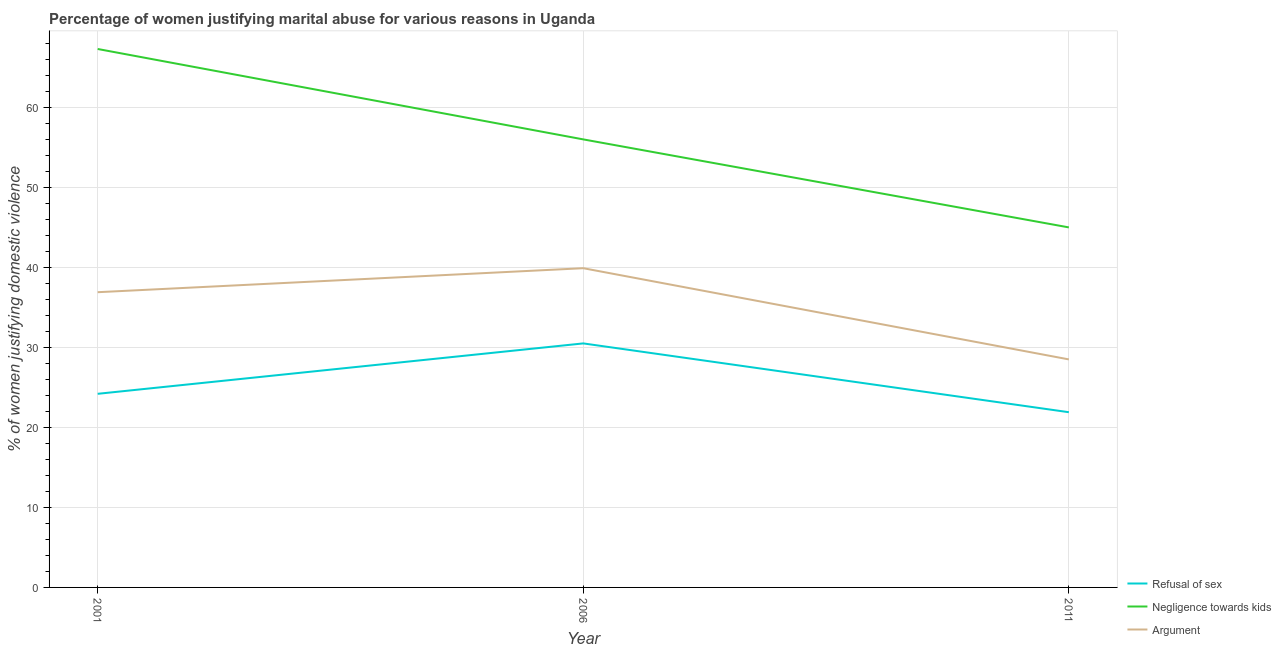How many different coloured lines are there?
Ensure brevity in your answer.  3. Does the line corresponding to percentage of women justifying domestic violence due to negligence towards kids intersect with the line corresponding to percentage of women justifying domestic violence due to arguments?
Give a very brief answer. No. Is the number of lines equal to the number of legend labels?
Make the answer very short. Yes. What is the percentage of women justifying domestic violence due to refusal of sex in 2011?
Your answer should be very brief. 21.9. Across all years, what is the maximum percentage of women justifying domestic violence due to refusal of sex?
Offer a very short reply. 30.5. In which year was the percentage of women justifying domestic violence due to negligence towards kids maximum?
Offer a very short reply. 2001. What is the total percentage of women justifying domestic violence due to refusal of sex in the graph?
Your answer should be compact. 76.6. What is the difference between the percentage of women justifying domestic violence due to negligence towards kids in 2001 and that in 2006?
Your answer should be compact. 11.3. What is the average percentage of women justifying domestic violence due to arguments per year?
Offer a terse response. 35.1. In the year 2011, what is the difference between the percentage of women justifying domestic violence due to arguments and percentage of women justifying domestic violence due to refusal of sex?
Ensure brevity in your answer.  6.6. In how many years, is the percentage of women justifying domestic violence due to refusal of sex greater than 60 %?
Keep it short and to the point. 0. What is the ratio of the percentage of women justifying domestic violence due to negligence towards kids in 2001 to that in 2011?
Provide a short and direct response. 1.5. Is the percentage of women justifying domestic violence due to refusal of sex in 2001 less than that in 2011?
Your response must be concise. No. What is the difference between the highest and the second highest percentage of women justifying domestic violence due to negligence towards kids?
Give a very brief answer. 11.3. What is the difference between the highest and the lowest percentage of women justifying domestic violence due to negligence towards kids?
Your response must be concise. 22.3. In how many years, is the percentage of women justifying domestic violence due to refusal of sex greater than the average percentage of women justifying domestic violence due to refusal of sex taken over all years?
Your answer should be compact. 1. Is it the case that in every year, the sum of the percentage of women justifying domestic violence due to refusal of sex and percentage of women justifying domestic violence due to negligence towards kids is greater than the percentage of women justifying domestic violence due to arguments?
Offer a terse response. Yes. Does the percentage of women justifying domestic violence due to negligence towards kids monotonically increase over the years?
Give a very brief answer. No. Is the percentage of women justifying domestic violence due to arguments strictly greater than the percentage of women justifying domestic violence due to negligence towards kids over the years?
Provide a short and direct response. No. How many years are there in the graph?
Offer a terse response. 3. What is the difference between two consecutive major ticks on the Y-axis?
Your answer should be very brief. 10. Are the values on the major ticks of Y-axis written in scientific E-notation?
Give a very brief answer. No. Does the graph contain any zero values?
Your answer should be very brief. No. Does the graph contain grids?
Your response must be concise. Yes. How many legend labels are there?
Offer a very short reply. 3. What is the title of the graph?
Make the answer very short. Percentage of women justifying marital abuse for various reasons in Uganda. What is the label or title of the Y-axis?
Offer a very short reply. % of women justifying domestic violence. What is the % of women justifying domestic violence of Refusal of sex in 2001?
Your answer should be very brief. 24.2. What is the % of women justifying domestic violence of Negligence towards kids in 2001?
Provide a short and direct response. 67.3. What is the % of women justifying domestic violence of Argument in 2001?
Provide a succinct answer. 36.9. What is the % of women justifying domestic violence of Refusal of sex in 2006?
Provide a succinct answer. 30.5. What is the % of women justifying domestic violence in Argument in 2006?
Give a very brief answer. 39.9. What is the % of women justifying domestic violence of Refusal of sex in 2011?
Your response must be concise. 21.9. What is the % of women justifying domestic violence in Negligence towards kids in 2011?
Offer a terse response. 45. Across all years, what is the maximum % of women justifying domestic violence in Refusal of sex?
Your response must be concise. 30.5. Across all years, what is the maximum % of women justifying domestic violence of Negligence towards kids?
Your answer should be very brief. 67.3. Across all years, what is the maximum % of women justifying domestic violence of Argument?
Provide a short and direct response. 39.9. Across all years, what is the minimum % of women justifying domestic violence in Refusal of sex?
Offer a very short reply. 21.9. Across all years, what is the minimum % of women justifying domestic violence in Negligence towards kids?
Your response must be concise. 45. What is the total % of women justifying domestic violence in Refusal of sex in the graph?
Give a very brief answer. 76.6. What is the total % of women justifying domestic violence of Negligence towards kids in the graph?
Ensure brevity in your answer.  168.3. What is the total % of women justifying domestic violence of Argument in the graph?
Offer a terse response. 105.3. What is the difference between the % of women justifying domestic violence in Negligence towards kids in 2001 and that in 2006?
Provide a succinct answer. 11.3. What is the difference between the % of women justifying domestic violence in Negligence towards kids in 2001 and that in 2011?
Provide a short and direct response. 22.3. What is the difference between the % of women justifying domestic violence of Argument in 2001 and that in 2011?
Offer a very short reply. 8.4. What is the difference between the % of women justifying domestic violence in Refusal of sex in 2006 and that in 2011?
Your answer should be very brief. 8.6. What is the difference between the % of women justifying domestic violence in Negligence towards kids in 2006 and that in 2011?
Provide a short and direct response. 11. What is the difference between the % of women justifying domestic violence of Refusal of sex in 2001 and the % of women justifying domestic violence of Negligence towards kids in 2006?
Your response must be concise. -31.8. What is the difference between the % of women justifying domestic violence in Refusal of sex in 2001 and the % of women justifying domestic violence in Argument in 2006?
Your response must be concise. -15.7. What is the difference between the % of women justifying domestic violence in Negligence towards kids in 2001 and the % of women justifying domestic violence in Argument in 2006?
Your answer should be very brief. 27.4. What is the difference between the % of women justifying domestic violence of Refusal of sex in 2001 and the % of women justifying domestic violence of Negligence towards kids in 2011?
Keep it short and to the point. -20.8. What is the difference between the % of women justifying domestic violence in Negligence towards kids in 2001 and the % of women justifying domestic violence in Argument in 2011?
Give a very brief answer. 38.8. What is the difference between the % of women justifying domestic violence in Refusal of sex in 2006 and the % of women justifying domestic violence in Negligence towards kids in 2011?
Your answer should be very brief. -14.5. What is the average % of women justifying domestic violence in Refusal of sex per year?
Your answer should be very brief. 25.53. What is the average % of women justifying domestic violence of Negligence towards kids per year?
Your answer should be very brief. 56.1. What is the average % of women justifying domestic violence of Argument per year?
Ensure brevity in your answer.  35.1. In the year 2001, what is the difference between the % of women justifying domestic violence in Refusal of sex and % of women justifying domestic violence in Negligence towards kids?
Ensure brevity in your answer.  -43.1. In the year 2001, what is the difference between the % of women justifying domestic violence in Refusal of sex and % of women justifying domestic violence in Argument?
Your answer should be very brief. -12.7. In the year 2001, what is the difference between the % of women justifying domestic violence of Negligence towards kids and % of women justifying domestic violence of Argument?
Provide a succinct answer. 30.4. In the year 2006, what is the difference between the % of women justifying domestic violence in Refusal of sex and % of women justifying domestic violence in Negligence towards kids?
Provide a short and direct response. -25.5. In the year 2006, what is the difference between the % of women justifying domestic violence of Negligence towards kids and % of women justifying domestic violence of Argument?
Keep it short and to the point. 16.1. In the year 2011, what is the difference between the % of women justifying domestic violence in Refusal of sex and % of women justifying domestic violence in Negligence towards kids?
Make the answer very short. -23.1. What is the ratio of the % of women justifying domestic violence of Refusal of sex in 2001 to that in 2006?
Your response must be concise. 0.79. What is the ratio of the % of women justifying domestic violence of Negligence towards kids in 2001 to that in 2006?
Offer a very short reply. 1.2. What is the ratio of the % of women justifying domestic violence of Argument in 2001 to that in 2006?
Your response must be concise. 0.92. What is the ratio of the % of women justifying domestic violence in Refusal of sex in 2001 to that in 2011?
Make the answer very short. 1.1. What is the ratio of the % of women justifying domestic violence of Negligence towards kids in 2001 to that in 2011?
Keep it short and to the point. 1.5. What is the ratio of the % of women justifying domestic violence in Argument in 2001 to that in 2011?
Offer a terse response. 1.29. What is the ratio of the % of women justifying domestic violence in Refusal of sex in 2006 to that in 2011?
Offer a very short reply. 1.39. What is the ratio of the % of women justifying domestic violence in Negligence towards kids in 2006 to that in 2011?
Offer a very short reply. 1.24. What is the ratio of the % of women justifying domestic violence in Argument in 2006 to that in 2011?
Your answer should be very brief. 1.4. What is the difference between the highest and the second highest % of women justifying domestic violence in Refusal of sex?
Provide a short and direct response. 6.3. What is the difference between the highest and the lowest % of women justifying domestic violence of Refusal of sex?
Your answer should be compact. 8.6. What is the difference between the highest and the lowest % of women justifying domestic violence of Negligence towards kids?
Your answer should be compact. 22.3. What is the difference between the highest and the lowest % of women justifying domestic violence in Argument?
Offer a very short reply. 11.4. 